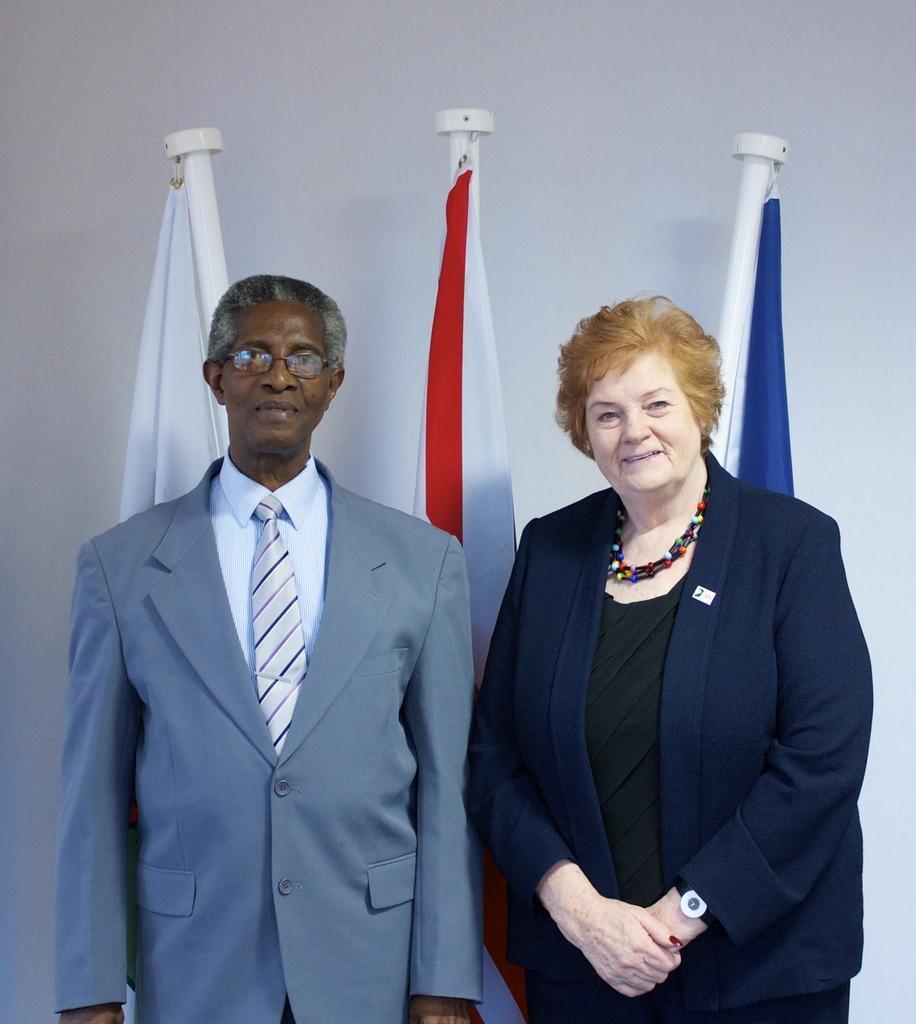How would you summarize this image in a sentence or two? In this picture, we can see there are two people standing on the floor and behind the people there are flags to the poles and a white wall. 